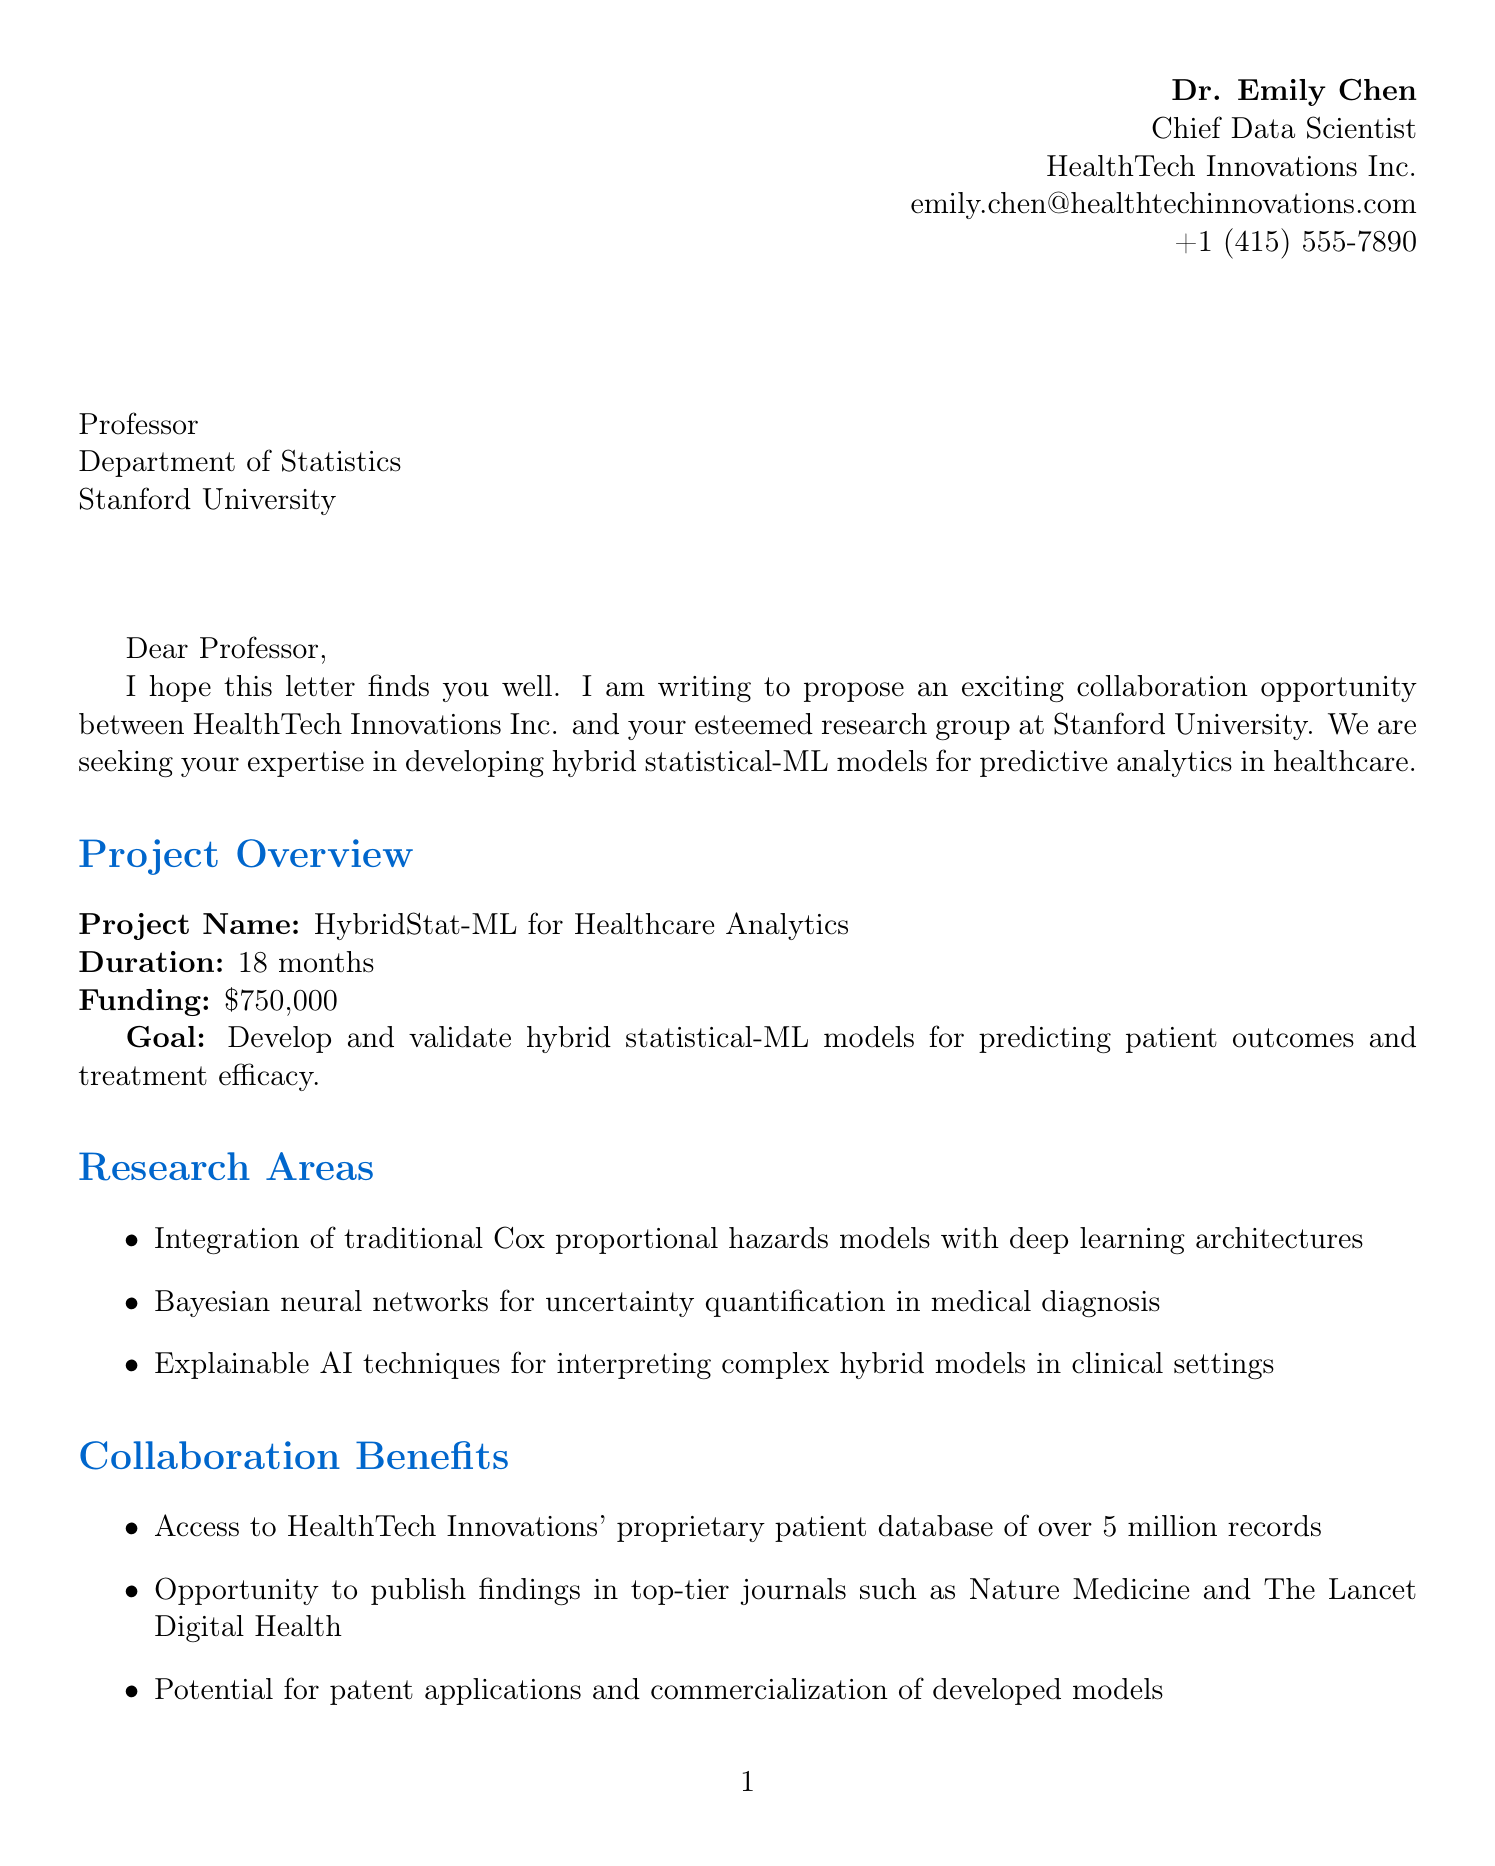What is the name of the project? The project is specifically named in the document as the "HybridStat-ML for Healthcare Analytics."
Answer: HybridStat-ML for Healthcare Analytics Who is the sender of the letter? The sender of the letter is detailed at the beginning of the document, specifically giving the name and title.
Answer: Dr. Emily Chen What is the total funding for the project? The amount of funding provided for the project is stated explicitly in the document.
Answer: $750,000 How long is the duration of the project? The document specifies the duration of the project as indicated in the project details.
Answer: 18 months What is one of the key research areas mentioned? One of the research areas is explicitly listed in the document under research areas.
Answer: Integration of traditional Cox proportional hazards models with deep learning architectures What are the required expertise areas? The document lists multiple expertise areas needed for collaboration, specifically focusing on statistical modeling and machine learning.
Answer: Advanced knowledge of statistical modeling techniques How often will meetings be conducted? The frequency of meetings is described as part of the collaboration logistics section in the document.
Answer: Bi-weekly video conferences What is the potential impact of the project? The document outlines several impacts, one of which is focused on the accuracy of predicting patient outcomes.
Answer: Improved accuracy in predicting patient outcomes for personalized treatment plans How many peer-reviewed publications are expected as deliverables? The number of publications that need to be produced is indicated under the deliverables section of the document.
Answer: Two peer-reviewed publications 